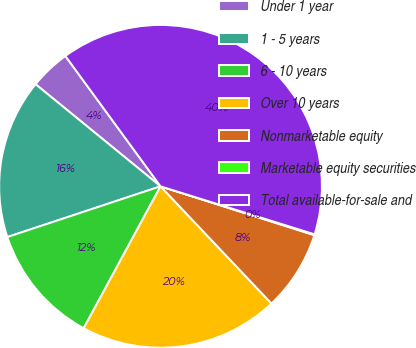<chart> <loc_0><loc_0><loc_500><loc_500><pie_chart><fcel>Under 1 year<fcel>1 - 5 years<fcel>6 - 10 years<fcel>Over 10 years<fcel>Nonmarketable equity<fcel>Marketable equity securities<fcel>Total available-for-sale and<nl><fcel>4.06%<fcel>15.99%<fcel>12.01%<fcel>19.96%<fcel>8.04%<fcel>0.09%<fcel>39.84%<nl></chart> 